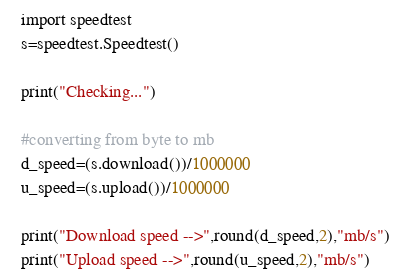Convert code to text. <code><loc_0><loc_0><loc_500><loc_500><_Python_>import speedtest
s=speedtest.Speedtest()

print("Checking...")

#converting from byte to mb 
d_speed=(s.download())/1000000
u_speed=(s.upload())/1000000

print("Download speed -->",round(d_speed,2),"mb/s")
print("Upload speed -->",round(u_speed,2),"mb/s")</code> 